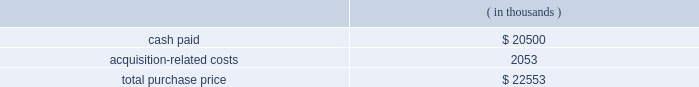Note 3 .
Business combinations purchase combinations .
During the fiscal years presented , the company made a number of purchase acquisitions .
For each acquisition , the excess of the purchase price over the estimated value of the net tangible assets acquired was allocated to various intangible assets , consisting primarily of developed technology , customer and contract-related assets and goodwill .
The values assigned to developed technologies related to each acquisition were based upon future discounted cash flows related to the existing products 2019 projected income streams .
Goodwill , representing the excess of the purchase consideration over the fair value of tangible and identifiable intangible assets acquired in the acquisitions , will not to be amortized .
Goodwill is not deductible for tax purposes .
The amounts allocated to purchased in-process research and developments were determined through established valuation techniques in the high-technology industry and were expensed upon acquisition because technological feasibility had not been established and no future alternative uses existed .
The consolidated financial statements include the operating results of each business from the date of acquisition .
The company does not consider these acquisitions to be material to its results of operations and is therefore not presenting pro forma statements of operations for the fiscal years ended october 31 , 2006 , 2005 and 2004 .
Fiscal 2006 acquisitions sigma-c software ag ( sigma-c ) the company acquired sigma-c on august 16 , 2006 in an all-cash transaction .
Reasons for the acquisition .
Sigma-c provides simulation software that allows semiconductor manufacturers and their suppliers to develop and optimize process sequences for optical lithography , e-beam lithography and next-generation lithography technologies .
The company believes the acquisition will enable a tighter integration between design and manufacturing tools , allowing the company 2019s customers to perform more accurate design layout analysis with 3d lithography simulation and better understand issues that affect ic wafer yields .
Purchase price .
The company paid $ 20.5 million in cash for the outstanding shares and shareholder notes of which $ 2.05 million was deposited with an escrow agent and will be paid per the escrow agreement .
The company believes that the escrow amount will be paid .
The total purchase consideration consisted of: .
Acquisition-related costs of $ 2.1 million consist primarily of legal , tax and accounting fees , estimated facilities closure costs and employee termination costs .
As of october 31 , 2006 , the company had paid $ 0.9 million of the acquisition-related costs .
The $ 1.2 million balance remaining at october 31 , 2006 primarily consists of legal , tax and accounting fees , estimated facilities closure costs and employee termination costs .
Assets acquired .
The company performed a preliminary valuation and allocated the total purchase consideration to assets and liabilities .
The company acquired $ 6.0 million of intangible assets consisting of $ 3.9 million in existing technology , $ 1.9 million in customer relationships and $ 0.2 million in trade names to be amortized over five years .
The company also acquired assets of $ 3.9 million and assumed liabilities of $ 5.1 million as result of this transaction .
Goodwill , representing the excess of the purchase price over the .
What is the percentage of the acquisition-related costs among the total purchase price? 
Rationale: it is the value of the acquisition-related costs divided by the total purchase price , then turned into a percentage .
Computations: (2053 / 22553)
Answer: 0.09103. 